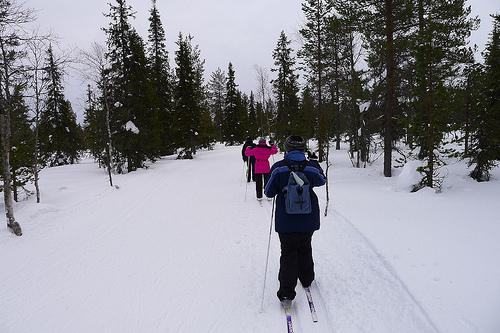Question: what marks the side of the trail?
Choices:
A. Trees.
B. Ribbons.
C. A fence.
D. Poles.
Answer with the letter. Answer: A Question: what is all over the ground?
Choices:
A. Leaves.
B. Grass.
C. Water.
D. Snow.
Answer with the letter. Answer: D Question: where was the shot taken?
Choices:
A. Eiffel Tower.
B. Ski slope.
C. The beach.
D. The playground.
Answer with the letter. Answer: B Question: what sport is in the photo?
Choices:
A. Tennis.
B. Snowboarding.
C. Skiing.
D. Football.
Answer with the letter. Answer: C 